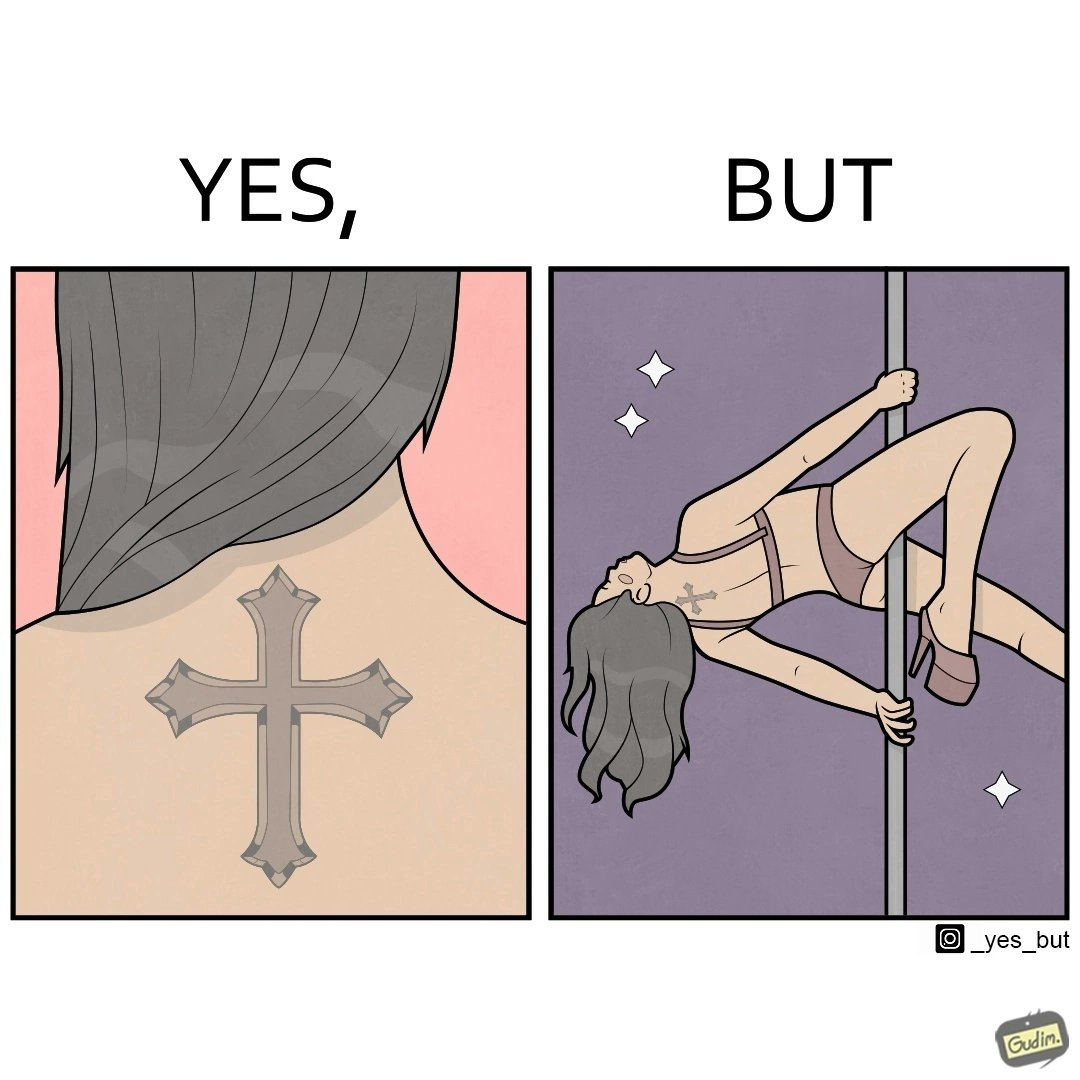Is this image satirical or non-satirical? Yes, this image is satirical. 